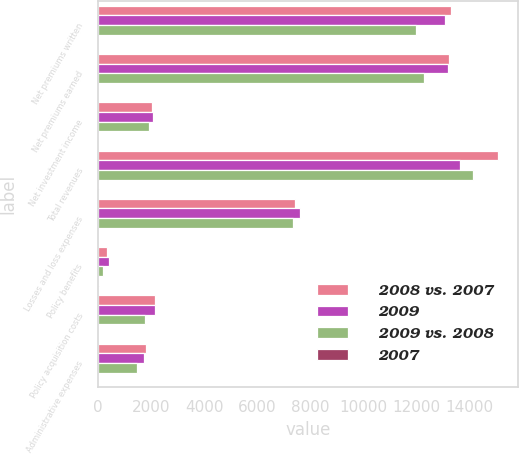<chart> <loc_0><loc_0><loc_500><loc_500><stacked_bar_chart><ecel><fcel>Net premiums written<fcel>Net premiums earned<fcel>Net investment income<fcel>Total revenues<fcel>Losses and loss expenses<fcel>Policy benefits<fcel>Policy acquisition costs<fcel>Administrative expenses<nl><fcel>2008 vs. 2007<fcel>13299<fcel>13240<fcel>2031<fcel>15075<fcel>7422<fcel>325<fcel>2130<fcel>1811<nl><fcel>2009<fcel>13080<fcel>13203<fcel>2062<fcel>13632<fcel>7603<fcel>399<fcel>2135<fcel>1737<nl><fcel>2009 vs. 2008<fcel>11979<fcel>12297<fcel>1918<fcel>14154<fcel>7351<fcel>168<fcel>1771<fcel>1455<nl><fcel>2007<fcel>2<fcel>0<fcel>2<fcel>11<fcel>2<fcel>19<fcel>0<fcel>4<nl></chart> 